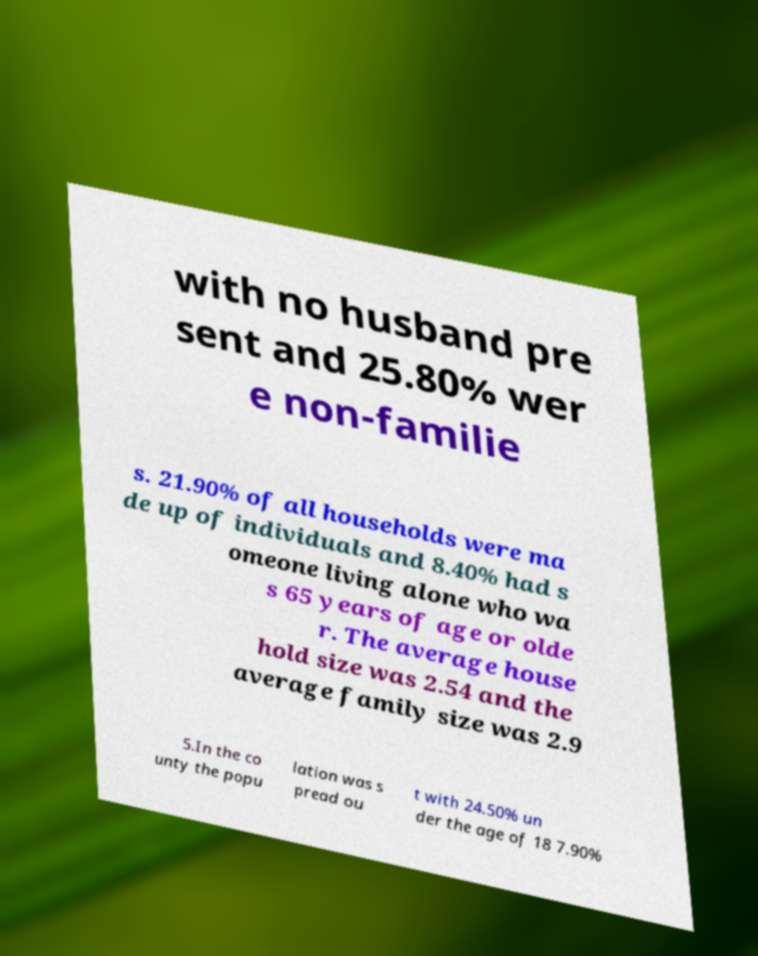There's text embedded in this image that I need extracted. Can you transcribe it verbatim? with no husband pre sent and 25.80% wer e non-familie s. 21.90% of all households were ma de up of individuals and 8.40% had s omeone living alone who wa s 65 years of age or olde r. The average house hold size was 2.54 and the average family size was 2.9 5.In the co unty the popu lation was s pread ou t with 24.50% un der the age of 18 7.90% 